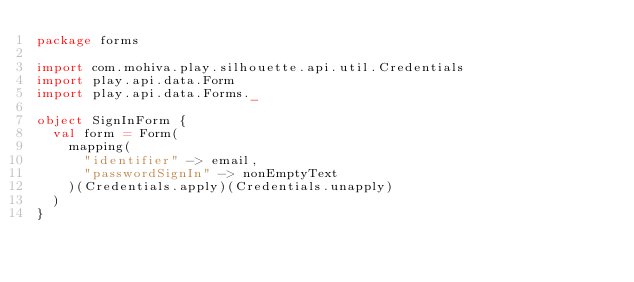<code> <loc_0><loc_0><loc_500><loc_500><_Scala_>package forms

import com.mohiva.play.silhouette.api.util.Credentials
import play.api.data.Form
import play.api.data.Forms._

object SignInForm {
  val form = Form(
    mapping(
      "identifier" -> email,
      "passwordSignIn" -> nonEmptyText
    )(Credentials.apply)(Credentials.unapply)
  )
}
</code> 